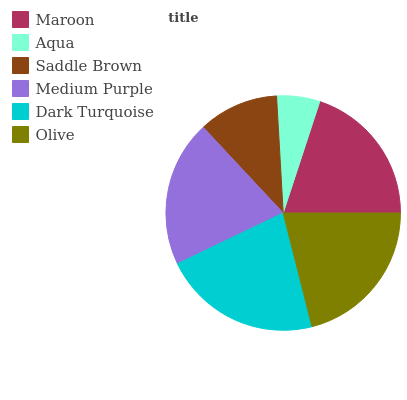Is Aqua the minimum?
Answer yes or no. Yes. Is Dark Turquoise the maximum?
Answer yes or no. Yes. Is Saddle Brown the minimum?
Answer yes or no. No. Is Saddle Brown the maximum?
Answer yes or no. No. Is Saddle Brown greater than Aqua?
Answer yes or no. Yes. Is Aqua less than Saddle Brown?
Answer yes or no. Yes. Is Aqua greater than Saddle Brown?
Answer yes or no. No. Is Saddle Brown less than Aqua?
Answer yes or no. No. Is Medium Purple the high median?
Answer yes or no. Yes. Is Maroon the low median?
Answer yes or no. Yes. Is Aqua the high median?
Answer yes or no. No. Is Dark Turquoise the low median?
Answer yes or no. No. 